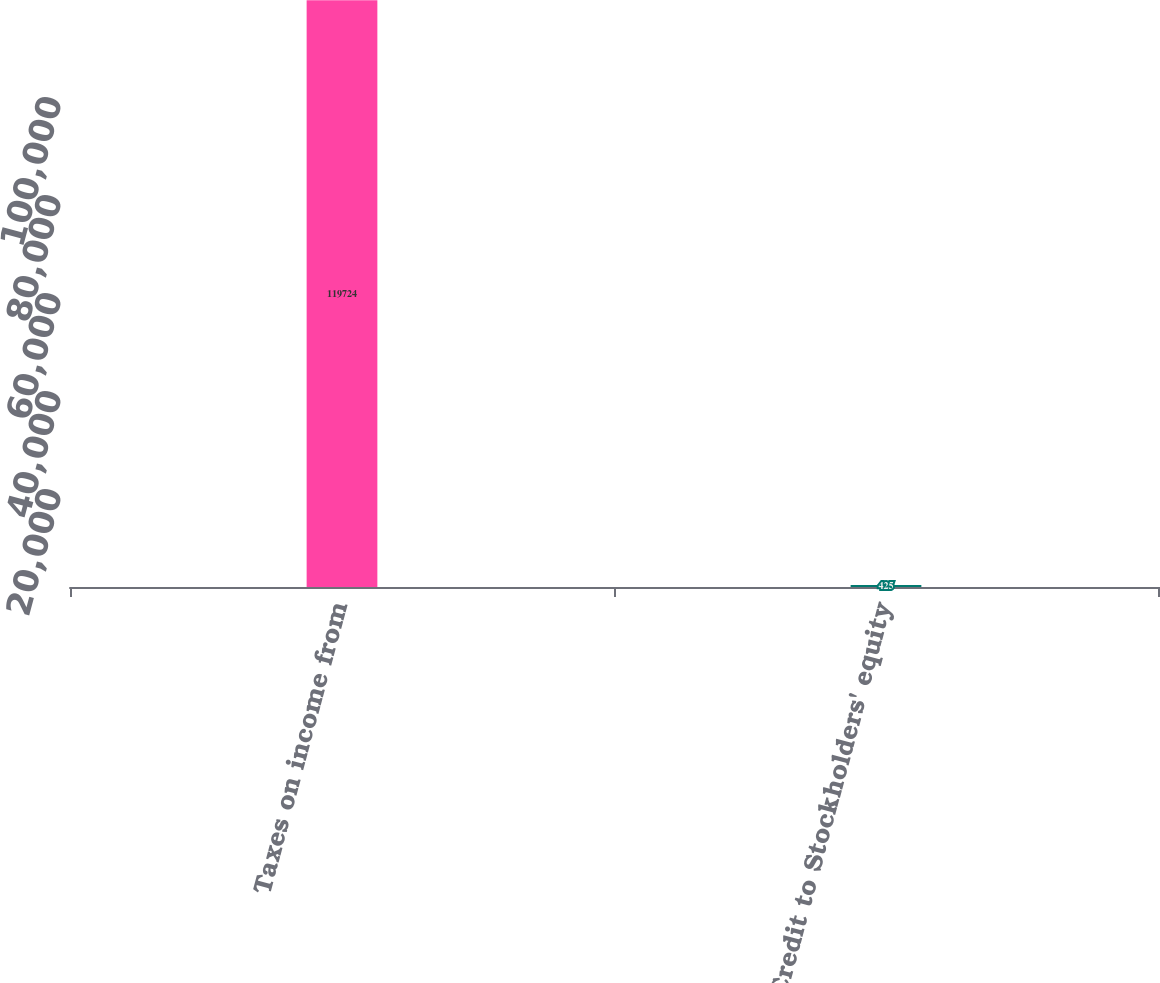<chart> <loc_0><loc_0><loc_500><loc_500><bar_chart><fcel>Taxes on income from<fcel>Credit to Stockholders' equity<nl><fcel>119724<fcel>425<nl></chart> 